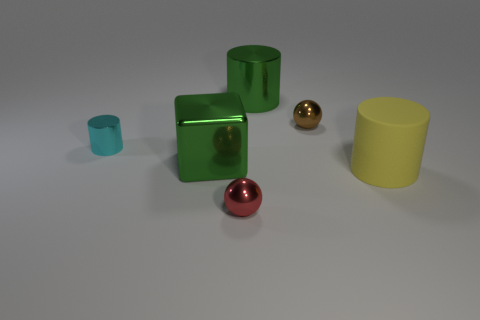Subtract all large green cylinders. How many cylinders are left? 2 Add 3 tiny red spheres. How many objects exist? 9 Subtract all yellow blocks. How many cyan cylinders are left? 1 Subtract all brown balls. How many balls are left? 1 Subtract all cubes. How many objects are left? 5 Subtract 1 cylinders. How many cylinders are left? 2 Subtract all gray cylinders. Subtract all brown blocks. How many cylinders are left? 3 Subtract 0 brown cylinders. How many objects are left? 6 Subtract all large brown matte spheres. Subtract all cyan cylinders. How many objects are left? 5 Add 2 green cylinders. How many green cylinders are left? 3 